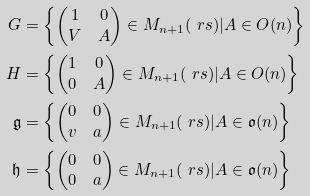<formula> <loc_0><loc_0><loc_500><loc_500>G & = \left \{ \begin{pmatrix} 1 & 0 \\ V & A \end{pmatrix} \in M _ { n + 1 } ( \ r s ) | A \in O ( n ) \right \} \\ H & = \left \{ \begin{pmatrix} 1 & 0 \\ 0 & A \end{pmatrix} \in M _ { n + 1 } ( \ r s ) | A \in O ( n ) \right \} \\ \mathfrak g & = \left \{ \begin{pmatrix} 0 & 0 \\ v & a \end{pmatrix} \in M _ { n + 1 } ( \ r s ) | A \in \mathfrak { o } ( n ) \right \} \\ \mathfrak h & = \left \{ \begin{pmatrix} 0 & 0 \\ 0 & a \end{pmatrix} \in M _ { n + 1 } ( \ r s ) | A \in \mathfrak { o } ( n ) \right \}</formula> 